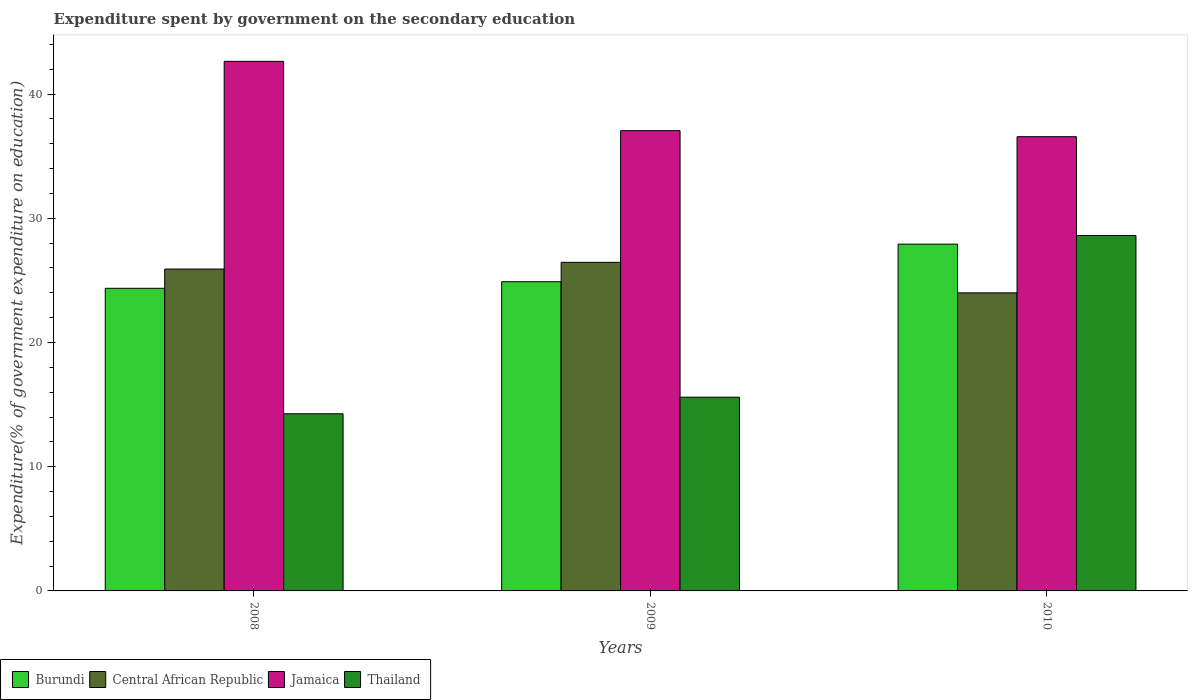How many different coloured bars are there?
Offer a very short reply. 4. How many groups of bars are there?
Make the answer very short. 3. Are the number of bars on each tick of the X-axis equal?
Provide a succinct answer. Yes. How many bars are there on the 3rd tick from the left?
Your response must be concise. 4. What is the label of the 2nd group of bars from the left?
Make the answer very short. 2009. What is the expenditure spent by government on the secondary education in Burundi in 2009?
Give a very brief answer. 24.89. Across all years, what is the maximum expenditure spent by government on the secondary education in Burundi?
Offer a very short reply. 27.92. Across all years, what is the minimum expenditure spent by government on the secondary education in Burundi?
Your answer should be very brief. 24.36. In which year was the expenditure spent by government on the secondary education in Thailand maximum?
Give a very brief answer. 2010. In which year was the expenditure spent by government on the secondary education in Central African Republic minimum?
Provide a succinct answer. 2010. What is the total expenditure spent by government on the secondary education in Thailand in the graph?
Keep it short and to the point. 58.47. What is the difference between the expenditure spent by government on the secondary education in Thailand in 2009 and that in 2010?
Ensure brevity in your answer.  -13.01. What is the difference between the expenditure spent by government on the secondary education in Burundi in 2010 and the expenditure spent by government on the secondary education in Thailand in 2009?
Your answer should be very brief. 12.32. What is the average expenditure spent by government on the secondary education in Thailand per year?
Offer a terse response. 19.49. In the year 2008, what is the difference between the expenditure spent by government on the secondary education in Thailand and expenditure spent by government on the secondary education in Jamaica?
Provide a short and direct response. -28.37. What is the ratio of the expenditure spent by government on the secondary education in Burundi in 2009 to that in 2010?
Ensure brevity in your answer.  0.89. Is the difference between the expenditure spent by government on the secondary education in Thailand in 2008 and 2009 greater than the difference between the expenditure spent by government on the secondary education in Jamaica in 2008 and 2009?
Ensure brevity in your answer.  No. What is the difference between the highest and the second highest expenditure spent by government on the secondary education in Central African Republic?
Provide a short and direct response. 0.54. What is the difference between the highest and the lowest expenditure spent by government on the secondary education in Thailand?
Give a very brief answer. 14.35. Is the sum of the expenditure spent by government on the secondary education in Burundi in 2008 and 2010 greater than the maximum expenditure spent by government on the secondary education in Central African Republic across all years?
Ensure brevity in your answer.  Yes. What does the 4th bar from the left in 2009 represents?
Ensure brevity in your answer.  Thailand. What does the 4th bar from the right in 2008 represents?
Your response must be concise. Burundi. What is the difference between two consecutive major ticks on the Y-axis?
Your answer should be very brief. 10. Are the values on the major ticks of Y-axis written in scientific E-notation?
Keep it short and to the point. No. Where does the legend appear in the graph?
Provide a short and direct response. Bottom left. How are the legend labels stacked?
Provide a short and direct response. Horizontal. What is the title of the graph?
Ensure brevity in your answer.  Expenditure spent by government on the secondary education. Does "Eritrea" appear as one of the legend labels in the graph?
Your response must be concise. No. What is the label or title of the X-axis?
Offer a very short reply. Years. What is the label or title of the Y-axis?
Your response must be concise. Expenditure(% of government expenditure on education). What is the Expenditure(% of government expenditure on education) of Burundi in 2008?
Your answer should be compact. 24.36. What is the Expenditure(% of government expenditure on education) of Central African Republic in 2008?
Your response must be concise. 25.91. What is the Expenditure(% of government expenditure on education) in Jamaica in 2008?
Your answer should be compact. 42.63. What is the Expenditure(% of government expenditure on education) of Thailand in 2008?
Give a very brief answer. 14.26. What is the Expenditure(% of government expenditure on education) of Burundi in 2009?
Offer a very short reply. 24.89. What is the Expenditure(% of government expenditure on education) in Central African Republic in 2009?
Provide a succinct answer. 26.45. What is the Expenditure(% of government expenditure on education) of Jamaica in 2009?
Ensure brevity in your answer.  37.05. What is the Expenditure(% of government expenditure on education) in Thailand in 2009?
Ensure brevity in your answer.  15.6. What is the Expenditure(% of government expenditure on education) in Burundi in 2010?
Make the answer very short. 27.92. What is the Expenditure(% of government expenditure on education) of Central African Republic in 2010?
Offer a terse response. 24. What is the Expenditure(% of government expenditure on education) in Jamaica in 2010?
Your answer should be very brief. 36.57. What is the Expenditure(% of government expenditure on education) of Thailand in 2010?
Offer a terse response. 28.61. Across all years, what is the maximum Expenditure(% of government expenditure on education) of Burundi?
Provide a succinct answer. 27.92. Across all years, what is the maximum Expenditure(% of government expenditure on education) in Central African Republic?
Provide a short and direct response. 26.45. Across all years, what is the maximum Expenditure(% of government expenditure on education) of Jamaica?
Offer a very short reply. 42.63. Across all years, what is the maximum Expenditure(% of government expenditure on education) of Thailand?
Keep it short and to the point. 28.61. Across all years, what is the minimum Expenditure(% of government expenditure on education) in Burundi?
Make the answer very short. 24.36. Across all years, what is the minimum Expenditure(% of government expenditure on education) of Central African Republic?
Offer a very short reply. 24. Across all years, what is the minimum Expenditure(% of government expenditure on education) of Jamaica?
Your response must be concise. 36.57. Across all years, what is the minimum Expenditure(% of government expenditure on education) in Thailand?
Ensure brevity in your answer.  14.26. What is the total Expenditure(% of government expenditure on education) of Burundi in the graph?
Ensure brevity in your answer.  77.17. What is the total Expenditure(% of government expenditure on education) in Central African Republic in the graph?
Make the answer very short. 76.36. What is the total Expenditure(% of government expenditure on education) in Jamaica in the graph?
Your response must be concise. 116.25. What is the total Expenditure(% of government expenditure on education) of Thailand in the graph?
Your response must be concise. 58.47. What is the difference between the Expenditure(% of government expenditure on education) in Burundi in 2008 and that in 2009?
Keep it short and to the point. -0.53. What is the difference between the Expenditure(% of government expenditure on education) of Central African Republic in 2008 and that in 2009?
Offer a very short reply. -0.54. What is the difference between the Expenditure(% of government expenditure on education) in Jamaica in 2008 and that in 2009?
Make the answer very short. 5.58. What is the difference between the Expenditure(% of government expenditure on education) in Thailand in 2008 and that in 2009?
Offer a very short reply. -1.34. What is the difference between the Expenditure(% of government expenditure on education) of Burundi in 2008 and that in 2010?
Provide a short and direct response. -3.56. What is the difference between the Expenditure(% of government expenditure on education) of Central African Republic in 2008 and that in 2010?
Provide a short and direct response. 1.92. What is the difference between the Expenditure(% of government expenditure on education) of Jamaica in 2008 and that in 2010?
Provide a succinct answer. 6.06. What is the difference between the Expenditure(% of government expenditure on education) in Thailand in 2008 and that in 2010?
Keep it short and to the point. -14.35. What is the difference between the Expenditure(% of government expenditure on education) in Burundi in 2009 and that in 2010?
Make the answer very short. -3.02. What is the difference between the Expenditure(% of government expenditure on education) of Central African Republic in 2009 and that in 2010?
Your answer should be compact. 2.46. What is the difference between the Expenditure(% of government expenditure on education) in Jamaica in 2009 and that in 2010?
Make the answer very short. 0.48. What is the difference between the Expenditure(% of government expenditure on education) in Thailand in 2009 and that in 2010?
Your answer should be compact. -13.01. What is the difference between the Expenditure(% of government expenditure on education) of Burundi in 2008 and the Expenditure(% of government expenditure on education) of Central African Republic in 2009?
Make the answer very short. -2.09. What is the difference between the Expenditure(% of government expenditure on education) of Burundi in 2008 and the Expenditure(% of government expenditure on education) of Jamaica in 2009?
Keep it short and to the point. -12.69. What is the difference between the Expenditure(% of government expenditure on education) in Burundi in 2008 and the Expenditure(% of government expenditure on education) in Thailand in 2009?
Give a very brief answer. 8.76. What is the difference between the Expenditure(% of government expenditure on education) in Central African Republic in 2008 and the Expenditure(% of government expenditure on education) in Jamaica in 2009?
Ensure brevity in your answer.  -11.14. What is the difference between the Expenditure(% of government expenditure on education) of Central African Republic in 2008 and the Expenditure(% of government expenditure on education) of Thailand in 2009?
Your response must be concise. 10.32. What is the difference between the Expenditure(% of government expenditure on education) of Jamaica in 2008 and the Expenditure(% of government expenditure on education) of Thailand in 2009?
Your answer should be very brief. 27.03. What is the difference between the Expenditure(% of government expenditure on education) of Burundi in 2008 and the Expenditure(% of government expenditure on education) of Central African Republic in 2010?
Provide a succinct answer. 0.37. What is the difference between the Expenditure(% of government expenditure on education) of Burundi in 2008 and the Expenditure(% of government expenditure on education) of Jamaica in 2010?
Keep it short and to the point. -12.21. What is the difference between the Expenditure(% of government expenditure on education) in Burundi in 2008 and the Expenditure(% of government expenditure on education) in Thailand in 2010?
Your answer should be compact. -4.25. What is the difference between the Expenditure(% of government expenditure on education) in Central African Republic in 2008 and the Expenditure(% of government expenditure on education) in Jamaica in 2010?
Your response must be concise. -10.65. What is the difference between the Expenditure(% of government expenditure on education) of Central African Republic in 2008 and the Expenditure(% of government expenditure on education) of Thailand in 2010?
Your response must be concise. -2.7. What is the difference between the Expenditure(% of government expenditure on education) in Jamaica in 2008 and the Expenditure(% of government expenditure on education) in Thailand in 2010?
Your answer should be compact. 14.02. What is the difference between the Expenditure(% of government expenditure on education) in Burundi in 2009 and the Expenditure(% of government expenditure on education) in Central African Republic in 2010?
Keep it short and to the point. 0.9. What is the difference between the Expenditure(% of government expenditure on education) of Burundi in 2009 and the Expenditure(% of government expenditure on education) of Jamaica in 2010?
Give a very brief answer. -11.67. What is the difference between the Expenditure(% of government expenditure on education) in Burundi in 2009 and the Expenditure(% of government expenditure on education) in Thailand in 2010?
Your answer should be very brief. -3.72. What is the difference between the Expenditure(% of government expenditure on education) of Central African Republic in 2009 and the Expenditure(% of government expenditure on education) of Jamaica in 2010?
Provide a succinct answer. -10.12. What is the difference between the Expenditure(% of government expenditure on education) in Central African Republic in 2009 and the Expenditure(% of government expenditure on education) in Thailand in 2010?
Make the answer very short. -2.16. What is the difference between the Expenditure(% of government expenditure on education) of Jamaica in 2009 and the Expenditure(% of government expenditure on education) of Thailand in 2010?
Offer a very short reply. 8.44. What is the average Expenditure(% of government expenditure on education) of Burundi per year?
Offer a terse response. 25.72. What is the average Expenditure(% of government expenditure on education) of Central African Republic per year?
Provide a succinct answer. 25.45. What is the average Expenditure(% of government expenditure on education) in Jamaica per year?
Offer a terse response. 38.75. What is the average Expenditure(% of government expenditure on education) of Thailand per year?
Give a very brief answer. 19.49. In the year 2008, what is the difference between the Expenditure(% of government expenditure on education) in Burundi and Expenditure(% of government expenditure on education) in Central African Republic?
Give a very brief answer. -1.55. In the year 2008, what is the difference between the Expenditure(% of government expenditure on education) of Burundi and Expenditure(% of government expenditure on education) of Jamaica?
Keep it short and to the point. -18.27. In the year 2008, what is the difference between the Expenditure(% of government expenditure on education) of Burundi and Expenditure(% of government expenditure on education) of Thailand?
Ensure brevity in your answer.  10.1. In the year 2008, what is the difference between the Expenditure(% of government expenditure on education) of Central African Republic and Expenditure(% of government expenditure on education) of Jamaica?
Keep it short and to the point. -16.72. In the year 2008, what is the difference between the Expenditure(% of government expenditure on education) of Central African Republic and Expenditure(% of government expenditure on education) of Thailand?
Provide a succinct answer. 11.65. In the year 2008, what is the difference between the Expenditure(% of government expenditure on education) in Jamaica and Expenditure(% of government expenditure on education) in Thailand?
Provide a short and direct response. 28.37. In the year 2009, what is the difference between the Expenditure(% of government expenditure on education) in Burundi and Expenditure(% of government expenditure on education) in Central African Republic?
Your answer should be compact. -1.56. In the year 2009, what is the difference between the Expenditure(% of government expenditure on education) in Burundi and Expenditure(% of government expenditure on education) in Jamaica?
Offer a very short reply. -12.16. In the year 2009, what is the difference between the Expenditure(% of government expenditure on education) of Burundi and Expenditure(% of government expenditure on education) of Thailand?
Offer a very short reply. 9.3. In the year 2009, what is the difference between the Expenditure(% of government expenditure on education) in Central African Republic and Expenditure(% of government expenditure on education) in Jamaica?
Keep it short and to the point. -10.6. In the year 2009, what is the difference between the Expenditure(% of government expenditure on education) in Central African Republic and Expenditure(% of government expenditure on education) in Thailand?
Offer a terse response. 10.85. In the year 2009, what is the difference between the Expenditure(% of government expenditure on education) in Jamaica and Expenditure(% of government expenditure on education) in Thailand?
Offer a very short reply. 21.45. In the year 2010, what is the difference between the Expenditure(% of government expenditure on education) in Burundi and Expenditure(% of government expenditure on education) in Central African Republic?
Ensure brevity in your answer.  3.92. In the year 2010, what is the difference between the Expenditure(% of government expenditure on education) in Burundi and Expenditure(% of government expenditure on education) in Jamaica?
Ensure brevity in your answer.  -8.65. In the year 2010, what is the difference between the Expenditure(% of government expenditure on education) in Burundi and Expenditure(% of government expenditure on education) in Thailand?
Offer a very short reply. -0.69. In the year 2010, what is the difference between the Expenditure(% of government expenditure on education) in Central African Republic and Expenditure(% of government expenditure on education) in Jamaica?
Give a very brief answer. -12.57. In the year 2010, what is the difference between the Expenditure(% of government expenditure on education) in Central African Republic and Expenditure(% of government expenditure on education) in Thailand?
Keep it short and to the point. -4.62. In the year 2010, what is the difference between the Expenditure(% of government expenditure on education) in Jamaica and Expenditure(% of government expenditure on education) in Thailand?
Offer a terse response. 7.96. What is the ratio of the Expenditure(% of government expenditure on education) of Burundi in 2008 to that in 2009?
Offer a terse response. 0.98. What is the ratio of the Expenditure(% of government expenditure on education) of Central African Republic in 2008 to that in 2009?
Make the answer very short. 0.98. What is the ratio of the Expenditure(% of government expenditure on education) in Jamaica in 2008 to that in 2009?
Your response must be concise. 1.15. What is the ratio of the Expenditure(% of government expenditure on education) of Thailand in 2008 to that in 2009?
Your answer should be very brief. 0.91. What is the ratio of the Expenditure(% of government expenditure on education) in Burundi in 2008 to that in 2010?
Provide a succinct answer. 0.87. What is the ratio of the Expenditure(% of government expenditure on education) in Central African Republic in 2008 to that in 2010?
Your answer should be compact. 1.08. What is the ratio of the Expenditure(% of government expenditure on education) in Jamaica in 2008 to that in 2010?
Offer a very short reply. 1.17. What is the ratio of the Expenditure(% of government expenditure on education) of Thailand in 2008 to that in 2010?
Your response must be concise. 0.5. What is the ratio of the Expenditure(% of government expenditure on education) in Burundi in 2009 to that in 2010?
Your answer should be very brief. 0.89. What is the ratio of the Expenditure(% of government expenditure on education) in Central African Republic in 2009 to that in 2010?
Your answer should be very brief. 1.1. What is the ratio of the Expenditure(% of government expenditure on education) of Jamaica in 2009 to that in 2010?
Your response must be concise. 1.01. What is the ratio of the Expenditure(% of government expenditure on education) in Thailand in 2009 to that in 2010?
Keep it short and to the point. 0.55. What is the difference between the highest and the second highest Expenditure(% of government expenditure on education) of Burundi?
Ensure brevity in your answer.  3.02. What is the difference between the highest and the second highest Expenditure(% of government expenditure on education) in Central African Republic?
Give a very brief answer. 0.54. What is the difference between the highest and the second highest Expenditure(% of government expenditure on education) in Jamaica?
Your answer should be compact. 5.58. What is the difference between the highest and the second highest Expenditure(% of government expenditure on education) in Thailand?
Provide a succinct answer. 13.01. What is the difference between the highest and the lowest Expenditure(% of government expenditure on education) in Burundi?
Provide a succinct answer. 3.56. What is the difference between the highest and the lowest Expenditure(% of government expenditure on education) of Central African Republic?
Give a very brief answer. 2.46. What is the difference between the highest and the lowest Expenditure(% of government expenditure on education) of Jamaica?
Provide a short and direct response. 6.06. What is the difference between the highest and the lowest Expenditure(% of government expenditure on education) of Thailand?
Give a very brief answer. 14.35. 